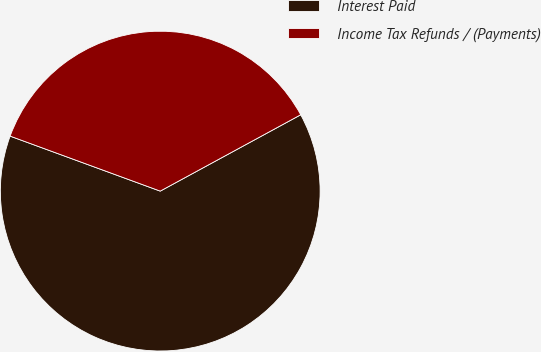<chart> <loc_0><loc_0><loc_500><loc_500><pie_chart><fcel>Interest Paid<fcel>Income Tax Refunds / (Payments)<nl><fcel>63.51%<fcel>36.49%<nl></chart> 